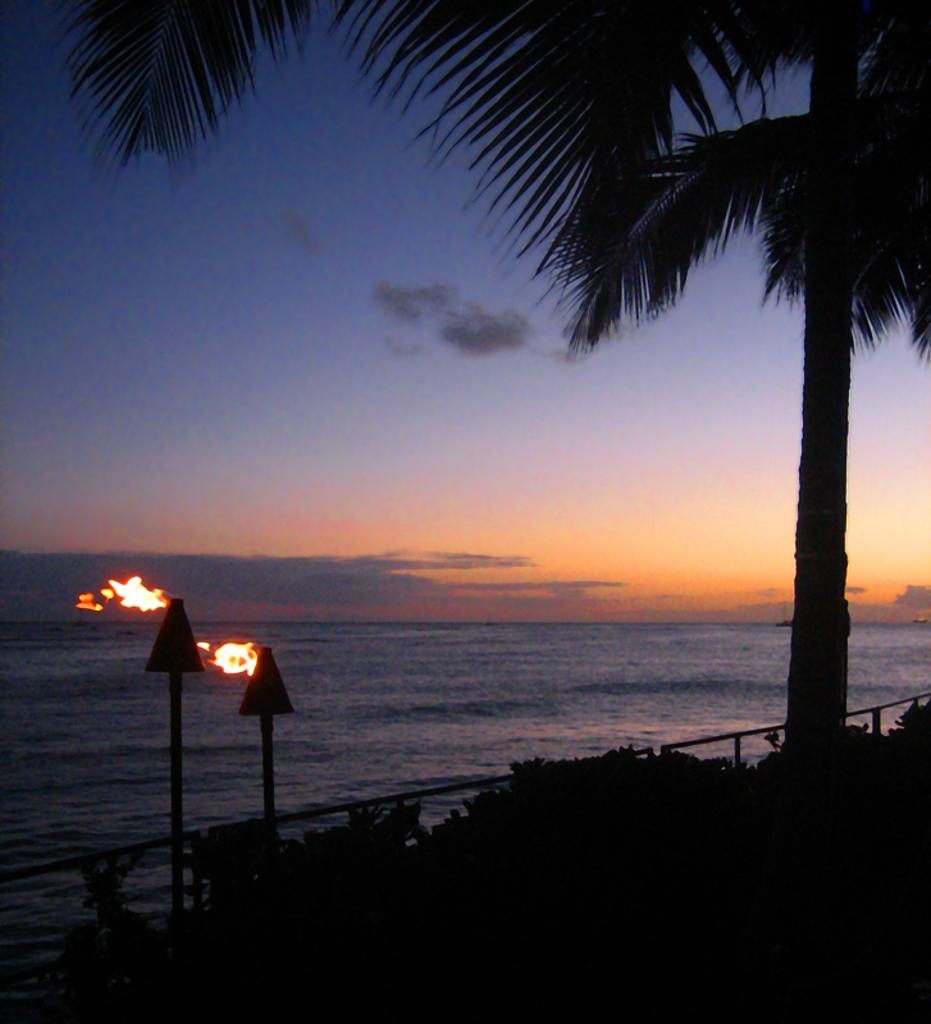What type of vegetation is on the right side of the image? There are trees on the right side of the image. What is located at the bottom of the image? There are boards at the bottom of the image. What type of barrier can be seen in the image? There is a fence in the image. What can be seen in the distance in the image? There is a sea visible in the background of the image. What else is visible in the background of the image? The sky is visible in the background of the image. How many visitors can be seen in the image? There are no visitors present in the image. What is the condition of the chin of the person in the image? There is no person present in the image, so it is not possible to determine the condition of their chin. 